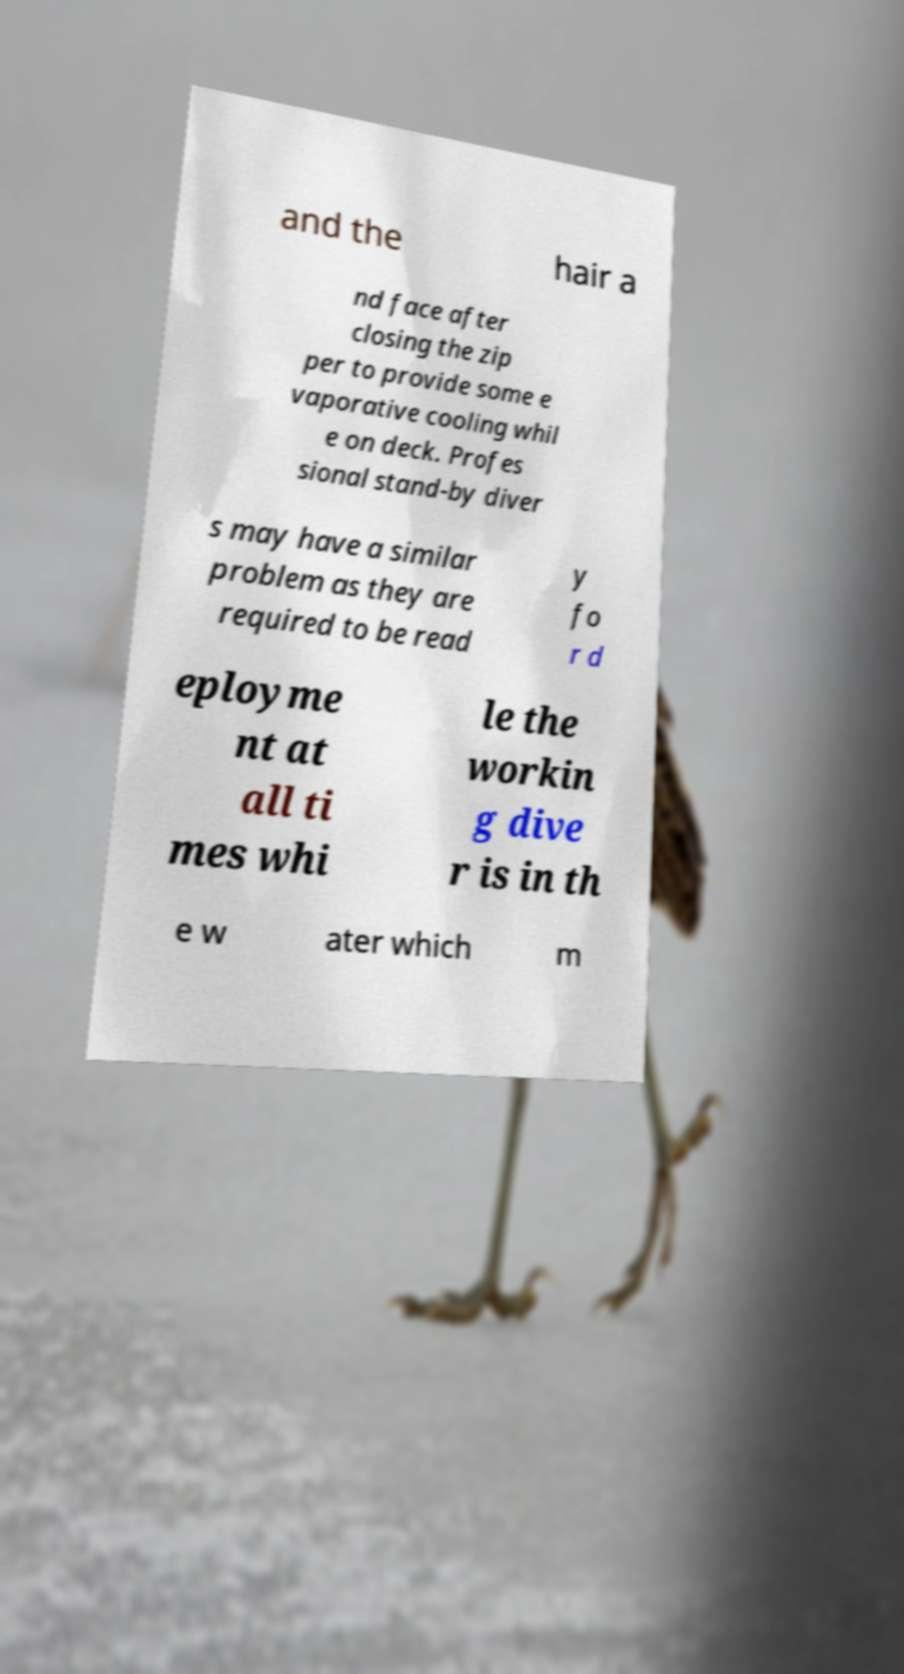What messages or text are displayed in this image? I need them in a readable, typed format. and the hair a nd face after closing the zip per to provide some e vaporative cooling whil e on deck. Profes sional stand-by diver s may have a similar problem as they are required to be read y fo r d eployme nt at all ti mes whi le the workin g dive r is in th e w ater which m 